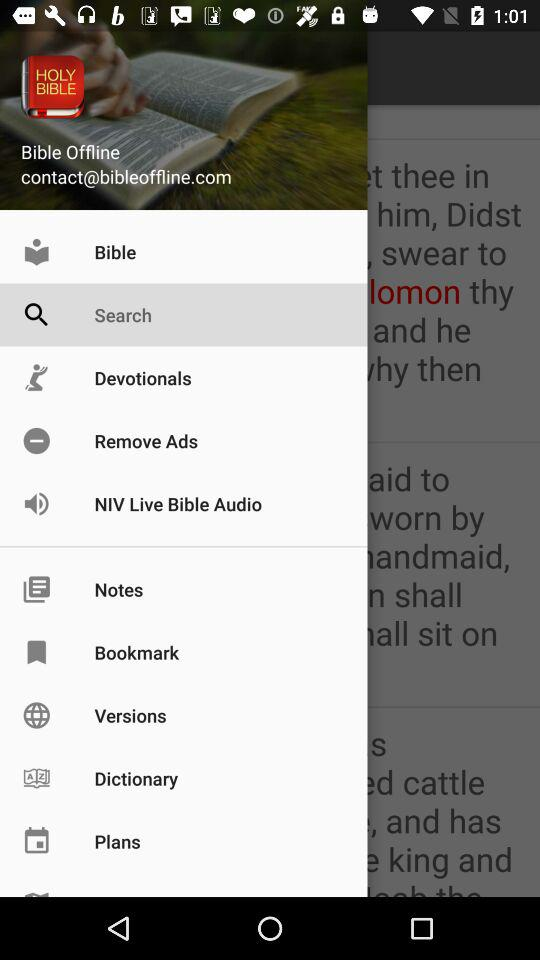Which item is selected? The selected item is "Search". 